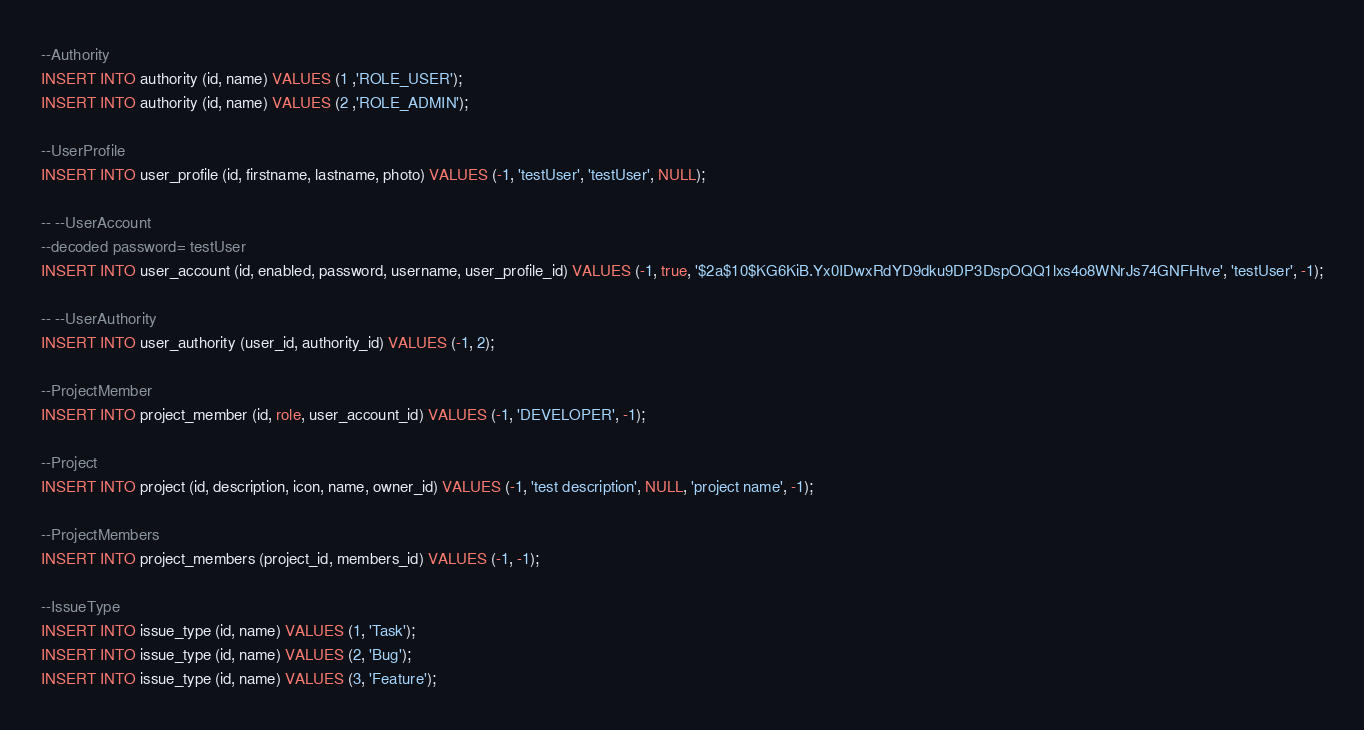<code> <loc_0><loc_0><loc_500><loc_500><_SQL_>--Authority
INSERT INTO authority (id, name) VALUES (1 ,'ROLE_USER');
INSERT INTO authority (id, name) VALUES (2 ,'ROLE_ADMIN');

--UserProfile
INSERT INTO user_profile (id, firstname, lastname, photo) VALUES (-1, 'testUser', 'testUser', NULL);

-- --UserAccount
--decoded password= testUser
INSERT INTO user_account (id, enabled, password, username, user_profile_id) VALUES (-1, true, '$2a$10$KG6KiB.Yx0IDwxRdYD9dku9DP3DspOQQ1lxs4o8WNrJs74GNFHtve', 'testUser', -1);

-- --UserAuthority
INSERT INTO user_authority (user_id, authority_id) VALUES (-1, 2);

--ProjectMember
INSERT INTO project_member (id, role, user_account_id) VALUES (-1, 'DEVELOPER', -1);

--Project
INSERT INTO project (id, description, icon, name, owner_id) VALUES (-1, 'test description', NULL, 'project name', -1);

--ProjectMembers
INSERT INTO project_members (project_id, members_id) VALUES (-1, -1);

--IssueType
INSERT INTO issue_type (id, name) VALUES (1, 'Task');
INSERT INTO issue_type (id, name) VALUES (2, 'Bug');
INSERT INTO issue_type (id, name) VALUES (3, 'Feature');</code> 